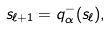Convert formula to latex. <formula><loc_0><loc_0><loc_500><loc_500>s _ { \ell + 1 } = q _ { \alpha } ^ { - } ( s _ { \ell } ) ,</formula> 